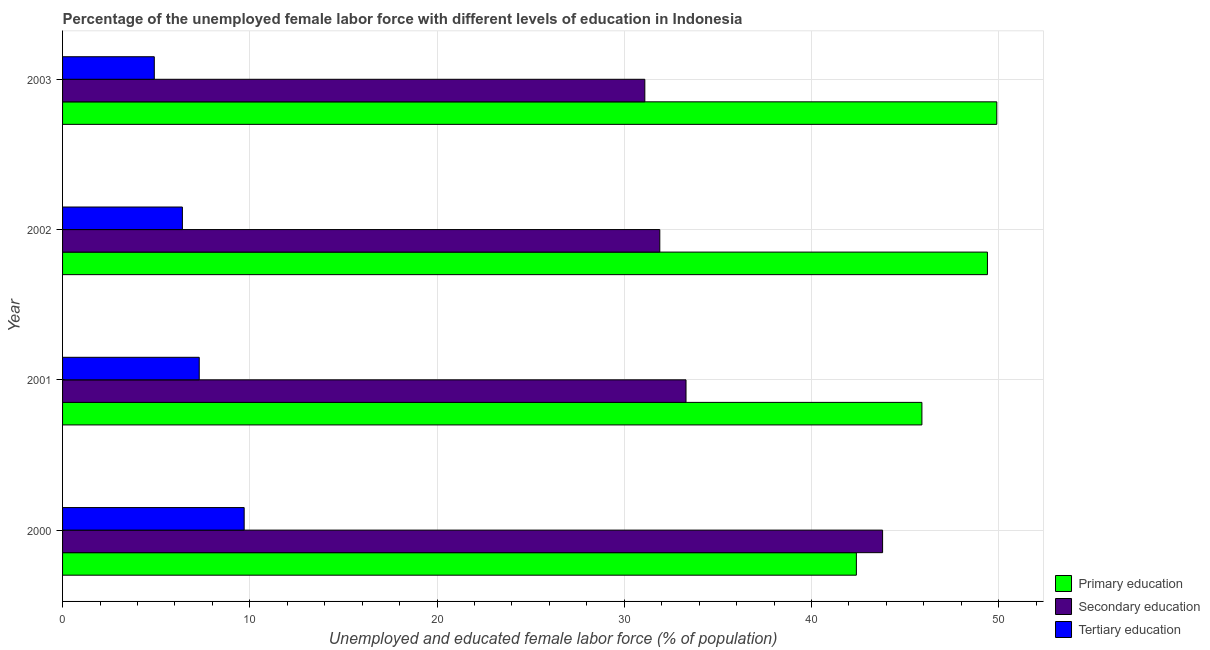How many different coloured bars are there?
Give a very brief answer. 3. How many groups of bars are there?
Your answer should be very brief. 4. Are the number of bars per tick equal to the number of legend labels?
Your answer should be compact. Yes. Are the number of bars on each tick of the Y-axis equal?
Provide a short and direct response. Yes. How many bars are there on the 1st tick from the top?
Keep it short and to the point. 3. In how many cases, is the number of bars for a given year not equal to the number of legend labels?
Keep it short and to the point. 0. What is the percentage of female labor force who received primary education in 2002?
Offer a terse response. 49.4. Across all years, what is the maximum percentage of female labor force who received primary education?
Provide a short and direct response. 49.9. Across all years, what is the minimum percentage of female labor force who received secondary education?
Offer a terse response. 31.1. In which year was the percentage of female labor force who received secondary education maximum?
Your answer should be very brief. 2000. In which year was the percentage of female labor force who received tertiary education minimum?
Provide a succinct answer. 2003. What is the total percentage of female labor force who received primary education in the graph?
Make the answer very short. 187.6. What is the difference between the percentage of female labor force who received primary education in 2003 and the percentage of female labor force who received secondary education in 2001?
Offer a terse response. 16.6. What is the average percentage of female labor force who received tertiary education per year?
Make the answer very short. 7.08. What is the ratio of the percentage of female labor force who received tertiary education in 2000 to that in 2001?
Your answer should be very brief. 1.33. Is the percentage of female labor force who received secondary education in 2000 less than that in 2001?
Give a very brief answer. No. What is the difference between the highest and the second highest percentage of female labor force who received primary education?
Provide a succinct answer. 0.5. In how many years, is the percentage of female labor force who received tertiary education greater than the average percentage of female labor force who received tertiary education taken over all years?
Make the answer very short. 2. Is the sum of the percentage of female labor force who received primary education in 2001 and 2003 greater than the maximum percentage of female labor force who received tertiary education across all years?
Make the answer very short. Yes. What does the 1st bar from the bottom in 2001 represents?
Keep it short and to the point. Primary education. Is it the case that in every year, the sum of the percentage of female labor force who received primary education and percentage of female labor force who received secondary education is greater than the percentage of female labor force who received tertiary education?
Your answer should be very brief. Yes. How many years are there in the graph?
Provide a short and direct response. 4. Does the graph contain any zero values?
Make the answer very short. No. Does the graph contain grids?
Your answer should be very brief. Yes. How many legend labels are there?
Make the answer very short. 3. How are the legend labels stacked?
Give a very brief answer. Vertical. What is the title of the graph?
Provide a short and direct response. Percentage of the unemployed female labor force with different levels of education in Indonesia. Does "New Zealand" appear as one of the legend labels in the graph?
Your answer should be compact. No. What is the label or title of the X-axis?
Your response must be concise. Unemployed and educated female labor force (% of population). What is the Unemployed and educated female labor force (% of population) in Primary education in 2000?
Your answer should be very brief. 42.4. What is the Unemployed and educated female labor force (% of population) of Secondary education in 2000?
Provide a short and direct response. 43.8. What is the Unemployed and educated female labor force (% of population) of Tertiary education in 2000?
Keep it short and to the point. 9.7. What is the Unemployed and educated female labor force (% of population) in Primary education in 2001?
Your answer should be very brief. 45.9. What is the Unemployed and educated female labor force (% of population) of Secondary education in 2001?
Make the answer very short. 33.3. What is the Unemployed and educated female labor force (% of population) in Tertiary education in 2001?
Give a very brief answer. 7.3. What is the Unemployed and educated female labor force (% of population) of Primary education in 2002?
Offer a very short reply. 49.4. What is the Unemployed and educated female labor force (% of population) in Secondary education in 2002?
Provide a short and direct response. 31.9. What is the Unemployed and educated female labor force (% of population) in Tertiary education in 2002?
Make the answer very short. 6.4. What is the Unemployed and educated female labor force (% of population) of Primary education in 2003?
Provide a succinct answer. 49.9. What is the Unemployed and educated female labor force (% of population) in Secondary education in 2003?
Give a very brief answer. 31.1. What is the Unemployed and educated female labor force (% of population) in Tertiary education in 2003?
Your answer should be compact. 4.9. Across all years, what is the maximum Unemployed and educated female labor force (% of population) of Primary education?
Provide a succinct answer. 49.9. Across all years, what is the maximum Unemployed and educated female labor force (% of population) of Secondary education?
Your answer should be very brief. 43.8. Across all years, what is the maximum Unemployed and educated female labor force (% of population) in Tertiary education?
Your response must be concise. 9.7. Across all years, what is the minimum Unemployed and educated female labor force (% of population) of Primary education?
Make the answer very short. 42.4. Across all years, what is the minimum Unemployed and educated female labor force (% of population) in Secondary education?
Your answer should be compact. 31.1. Across all years, what is the minimum Unemployed and educated female labor force (% of population) of Tertiary education?
Ensure brevity in your answer.  4.9. What is the total Unemployed and educated female labor force (% of population) in Primary education in the graph?
Offer a terse response. 187.6. What is the total Unemployed and educated female labor force (% of population) of Secondary education in the graph?
Offer a very short reply. 140.1. What is the total Unemployed and educated female labor force (% of population) in Tertiary education in the graph?
Provide a succinct answer. 28.3. What is the difference between the Unemployed and educated female labor force (% of population) in Primary education in 2000 and that in 2001?
Keep it short and to the point. -3.5. What is the difference between the Unemployed and educated female labor force (% of population) in Secondary education in 2000 and that in 2001?
Your answer should be compact. 10.5. What is the difference between the Unemployed and educated female labor force (% of population) of Primary education in 2001 and that in 2003?
Provide a succinct answer. -4. What is the difference between the Unemployed and educated female labor force (% of population) of Primary education in 2002 and that in 2003?
Make the answer very short. -0.5. What is the difference between the Unemployed and educated female labor force (% of population) of Primary education in 2000 and the Unemployed and educated female labor force (% of population) of Tertiary education in 2001?
Provide a short and direct response. 35.1. What is the difference between the Unemployed and educated female labor force (% of population) in Secondary education in 2000 and the Unemployed and educated female labor force (% of population) in Tertiary education in 2001?
Your response must be concise. 36.5. What is the difference between the Unemployed and educated female labor force (% of population) in Primary education in 2000 and the Unemployed and educated female labor force (% of population) in Secondary education in 2002?
Offer a very short reply. 10.5. What is the difference between the Unemployed and educated female labor force (% of population) in Primary education in 2000 and the Unemployed and educated female labor force (% of population) in Tertiary education in 2002?
Your answer should be compact. 36. What is the difference between the Unemployed and educated female labor force (% of population) in Secondary education in 2000 and the Unemployed and educated female labor force (% of population) in Tertiary education in 2002?
Your response must be concise. 37.4. What is the difference between the Unemployed and educated female labor force (% of population) in Primary education in 2000 and the Unemployed and educated female labor force (% of population) in Tertiary education in 2003?
Ensure brevity in your answer.  37.5. What is the difference between the Unemployed and educated female labor force (% of population) of Secondary education in 2000 and the Unemployed and educated female labor force (% of population) of Tertiary education in 2003?
Give a very brief answer. 38.9. What is the difference between the Unemployed and educated female labor force (% of population) of Primary education in 2001 and the Unemployed and educated female labor force (% of population) of Tertiary education in 2002?
Provide a succinct answer. 39.5. What is the difference between the Unemployed and educated female labor force (% of population) in Secondary education in 2001 and the Unemployed and educated female labor force (% of population) in Tertiary education in 2002?
Ensure brevity in your answer.  26.9. What is the difference between the Unemployed and educated female labor force (% of population) in Primary education in 2001 and the Unemployed and educated female labor force (% of population) in Secondary education in 2003?
Give a very brief answer. 14.8. What is the difference between the Unemployed and educated female labor force (% of population) in Primary education in 2001 and the Unemployed and educated female labor force (% of population) in Tertiary education in 2003?
Offer a terse response. 41. What is the difference between the Unemployed and educated female labor force (% of population) in Secondary education in 2001 and the Unemployed and educated female labor force (% of population) in Tertiary education in 2003?
Offer a terse response. 28.4. What is the difference between the Unemployed and educated female labor force (% of population) of Primary education in 2002 and the Unemployed and educated female labor force (% of population) of Tertiary education in 2003?
Ensure brevity in your answer.  44.5. What is the difference between the Unemployed and educated female labor force (% of population) of Secondary education in 2002 and the Unemployed and educated female labor force (% of population) of Tertiary education in 2003?
Offer a terse response. 27. What is the average Unemployed and educated female labor force (% of population) of Primary education per year?
Give a very brief answer. 46.9. What is the average Unemployed and educated female labor force (% of population) of Secondary education per year?
Give a very brief answer. 35.02. What is the average Unemployed and educated female labor force (% of population) in Tertiary education per year?
Ensure brevity in your answer.  7.08. In the year 2000, what is the difference between the Unemployed and educated female labor force (% of population) in Primary education and Unemployed and educated female labor force (% of population) in Secondary education?
Provide a short and direct response. -1.4. In the year 2000, what is the difference between the Unemployed and educated female labor force (% of population) in Primary education and Unemployed and educated female labor force (% of population) in Tertiary education?
Provide a short and direct response. 32.7. In the year 2000, what is the difference between the Unemployed and educated female labor force (% of population) in Secondary education and Unemployed and educated female labor force (% of population) in Tertiary education?
Offer a very short reply. 34.1. In the year 2001, what is the difference between the Unemployed and educated female labor force (% of population) of Primary education and Unemployed and educated female labor force (% of population) of Secondary education?
Offer a very short reply. 12.6. In the year 2001, what is the difference between the Unemployed and educated female labor force (% of population) of Primary education and Unemployed and educated female labor force (% of population) of Tertiary education?
Keep it short and to the point. 38.6. In the year 2002, what is the difference between the Unemployed and educated female labor force (% of population) in Primary education and Unemployed and educated female labor force (% of population) in Secondary education?
Make the answer very short. 17.5. In the year 2002, what is the difference between the Unemployed and educated female labor force (% of population) in Secondary education and Unemployed and educated female labor force (% of population) in Tertiary education?
Make the answer very short. 25.5. In the year 2003, what is the difference between the Unemployed and educated female labor force (% of population) of Primary education and Unemployed and educated female labor force (% of population) of Secondary education?
Keep it short and to the point. 18.8. In the year 2003, what is the difference between the Unemployed and educated female labor force (% of population) of Primary education and Unemployed and educated female labor force (% of population) of Tertiary education?
Your answer should be compact. 45. In the year 2003, what is the difference between the Unemployed and educated female labor force (% of population) of Secondary education and Unemployed and educated female labor force (% of population) of Tertiary education?
Give a very brief answer. 26.2. What is the ratio of the Unemployed and educated female labor force (% of population) of Primary education in 2000 to that in 2001?
Your answer should be compact. 0.92. What is the ratio of the Unemployed and educated female labor force (% of population) in Secondary education in 2000 to that in 2001?
Ensure brevity in your answer.  1.32. What is the ratio of the Unemployed and educated female labor force (% of population) of Tertiary education in 2000 to that in 2001?
Ensure brevity in your answer.  1.33. What is the ratio of the Unemployed and educated female labor force (% of population) in Primary education in 2000 to that in 2002?
Ensure brevity in your answer.  0.86. What is the ratio of the Unemployed and educated female labor force (% of population) of Secondary education in 2000 to that in 2002?
Ensure brevity in your answer.  1.37. What is the ratio of the Unemployed and educated female labor force (% of population) of Tertiary education in 2000 to that in 2002?
Your answer should be compact. 1.52. What is the ratio of the Unemployed and educated female labor force (% of population) in Primary education in 2000 to that in 2003?
Provide a short and direct response. 0.85. What is the ratio of the Unemployed and educated female labor force (% of population) in Secondary education in 2000 to that in 2003?
Your answer should be compact. 1.41. What is the ratio of the Unemployed and educated female labor force (% of population) in Tertiary education in 2000 to that in 2003?
Make the answer very short. 1.98. What is the ratio of the Unemployed and educated female labor force (% of population) of Primary education in 2001 to that in 2002?
Your answer should be compact. 0.93. What is the ratio of the Unemployed and educated female labor force (% of population) of Secondary education in 2001 to that in 2002?
Provide a short and direct response. 1.04. What is the ratio of the Unemployed and educated female labor force (% of population) in Tertiary education in 2001 to that in 2002?
Your response must be concise. 1.14. What is the ratio of the Unemployed and educated female labor force (% of population) in Primary education in 2001 to that in 2003?
Provide a succinct answer. 0.92. What is the ratio of the Unemployed and educated female labor force (% of population) of Secondary education in 2001 to that in 2003?
Your answer should be very brief. 1.07. What is the ratio of the Unemployed and educated female labor force (% of population) in Tertiary education in 2001 to that in 2003?
Your answer should be very brief. 1.49. What is the ratio of the Unemployed and educated female labor force (% of population) in Secondary education in 2002 to that in 2003?
Offer a terse response. 1.03. What is the ratio of the Unemployed and educated female labor force (% of population) of Tertiary education in 2002 to that in 2003?
Offer a very short reply. 1.31. What is the difference between the highest and the second highest Unemployed and educated female labor force (% of population) of Primary education?
Your response must be concise. 0.5. What is the difference between the highest and the second highest Unemployed and educated female labor force (% of population) of Secondary education?
Provide a succinct answer. 10.5. What is the difference between the highest and the second highest Unemployed and educated female labor force (% of population) of Tertiary education?
Keep it short and to the point. 2.4. What is the difference between the highest and the lowest Unemployed and educated female labor force (% of population) of Tertiary education?
Your answer should be compact. 4.8. 